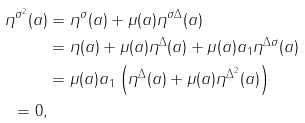Convert formula to latex. <formula><loc_0><loc_0><loc_500><loc_500>\eta ^ { \sigma ^ { 2 } } ( a ) & = \eta ^ { \sigma } ( a ) + \mu ( a ) \eta ^ { \sigma \Delta } ( a ) \\ & = \eta ( a ) + \mu ( a ) \eta ^ { \Delta } ( a ) + \mu ( a ) a _ { 1 } \eta ^ { \Delta \sigma } ( a ) \\ & = \mu ( a ) a _ { 1 } \left ( \eta ^ { \Delta } ( a ) + \mu ( a ) \eta ^ { \Delta ^ { 2 } } ( a ) \right ) \\ = 0 ,</formula> 